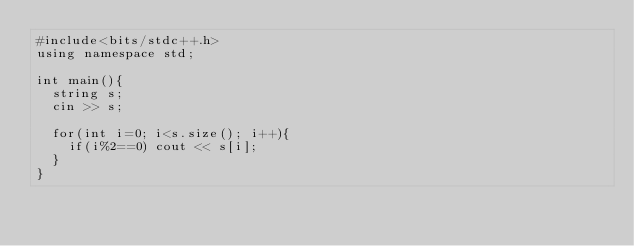Convert code to text. <code><loc_0><loc_0><loc_500><loc_500><_C++_>#include<bits/stdc++.h>
using namespace std;

int main(){
  string s;
  cin >> s;
  
  for(int i=0; i<s.size(); i++){
    if(i%2==0) cout << s[i];
  }
}
</code> 